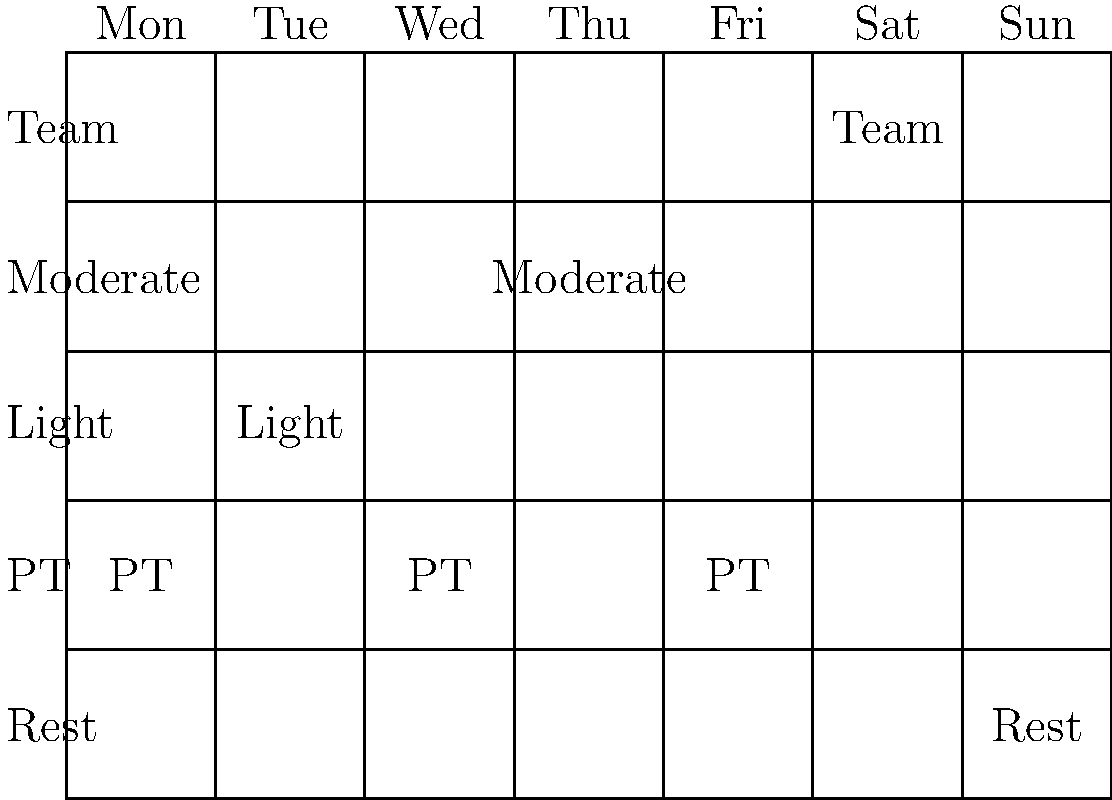Based on the weekly training schedule shown for a rugby player returning from injury, which day is allocated for full team practice? To determine the day allocated for full team practice, we need to analyze the weekly calendar provided:

1. The calendar shows a week from Monday to Sunday.
2. There are different levels of activity: Rest, PT (Physical Therapy), Light, Moderate, and Team.
3. Looking at each day:
   - Monday: PT
   - Tuesday: Light training
   - Wednesday: PT
   - Thursday: Moderate training
   - Friday: PT
   - Saturday: Team practice
   - Sunday: Rest

4. The "Team" level of activity, which indicates full team practice, is scheduled for Saturday.

Therefore, the day allocated for full team practice is Saturday.
Answer: Saturday 